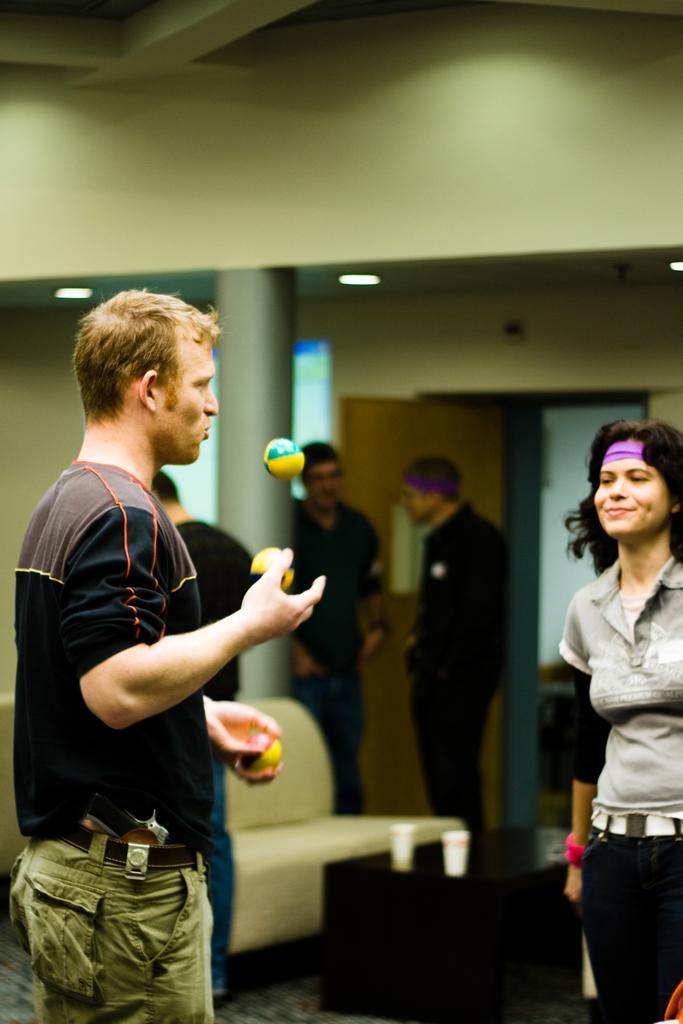Describe this image in one or two sentences. In the foreground of this image, on the right, there is a woman and on the left, there is a man standing and playing with balls. In the background, there is a couch, two glasses on the table, three men staidness, wall, pillar, door, lights and the ceiling. 